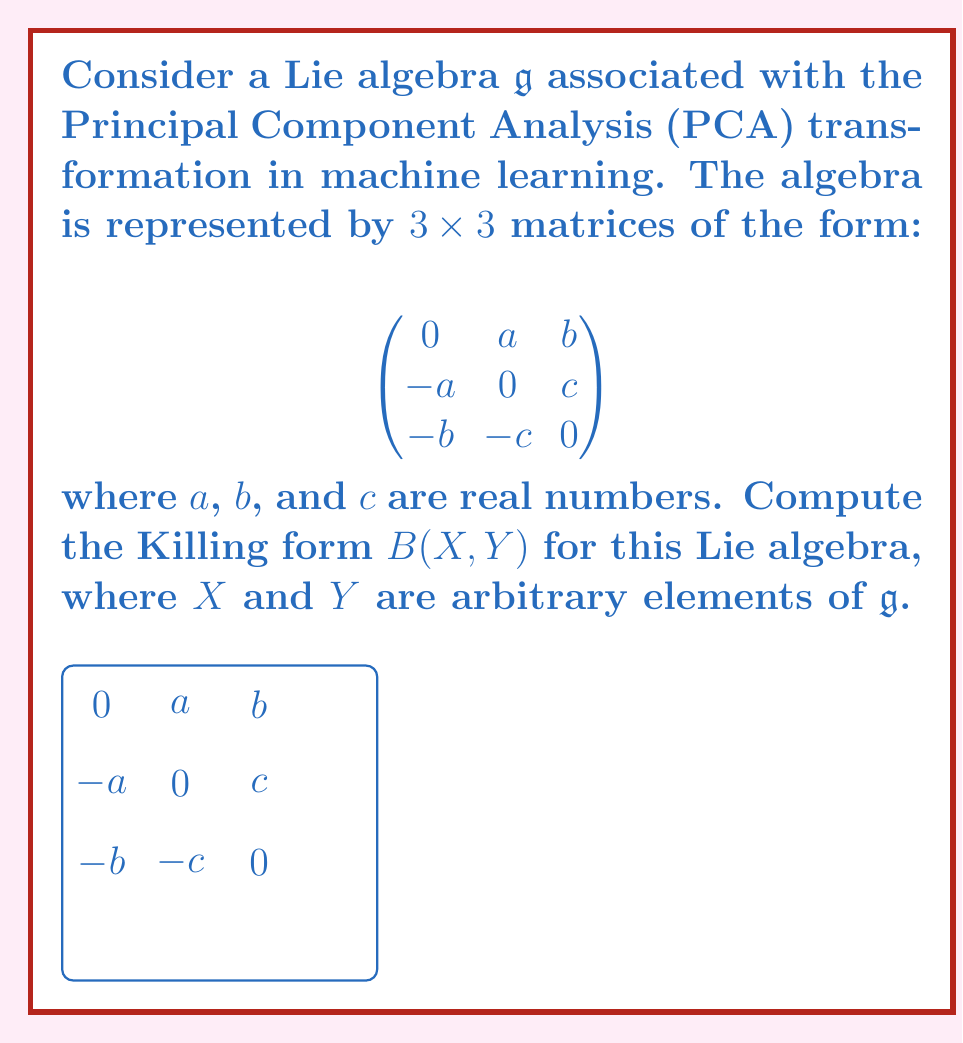Give your solution to this math problem. Let's approach this step-by-step:

1) The Killing form $B(X, Y)$ is defined as $B(X, Y) = \text{tr}(\text{ad}(X) \circ \text{ad}(Y))$, where $\text{ad}$ denotes the adjoint representation and $\text{tr}$ is the trace.

2) For our Lie algebra, let's define two arbitrary elements $X$ and $Y$:

   $$X = \begin{pmatrix}
   0 & a_1 & b_1 \\
   -a_1 & 0 & c_1 \\
   -b_1 & -c_1 & 0
   \end{pmatrix}, \quad
   Y = \begin{pmatrix}
   0 & a_2 & b_2 \\
   -a_2 & 0 & c_2 \\
   -b_2 & -c_2 & 0
   \end{pmatrix}$$

3) To compute $\text{ad}(X)$, we need to calculate $[X, Z]$ for a generic element $Z$ of the algebra:

   $$Z = \begin{pmatrix}
   0 & x & y \\
   -x & 0 & z \\
   -y & -z & 0
   \end{pmatrix}$$

4) Computing $[X, Z] = XZ - ZX$:

   $$[X, Z] = \begin{pmatrix}
   0 & c_1y - b_1z & -c_1x + a_1z \\
   -c_1y + b_1z & 0 & a_1x - b_1y \\
   c_1x - a_1z & -a_1x + b_1y & 0
   \end{pmatrix}$$

5) From this, we can deduce the matrix representation of $\text{ad}(X)$:

   $$\text{ad}(X) = \begin{pmatrix}
   0 & -c_1 & b_1 \\
   c_1 & 0 & -a_1 \\
   -b_1 & a_1 & 0
   \end{pmatrix}$$

6) Similarly for $Y$:

   $$\text{ad}(Y) = \begin{pmatrix}
   0 & -c_2 & b_2 \\
   c_2 & 0 & -a_2 \\
   -b_2 & a_2 & 0
   \end{pmatrix}$$

7) Now, we compute $\text{ad}(X) \circ \text{ad}(Y)$:

   $$\text{ad}(X) \circ \text{ad}(Y) = \begin{pmatrix}
   -b_1b_2 - c_1c_2 & a_1b_2 & a_1c_2 \\
   -a_2c_1 & -a_1a_2 - c_1c_2 & b_1a_2 \\
   b_2c_1 & -b_1c_2 & -a_1a_2 - b_1b_2
   \end{pmatrix}$$

8) The Killing form is the trace of this matrix:

   $$B(X, Y) = \text{tr}(\text{ad}(X) \circ \text{ad}(Y)) = -2(a_1a_2 + b_1b_2 + c_1c_2)$$

This is the Killing form for our Lie algebra associated with PCA transformations.
Answer: $B(X, Y) = -2(a_1a_2 + b_1b_2 + c_1c_2)$ 